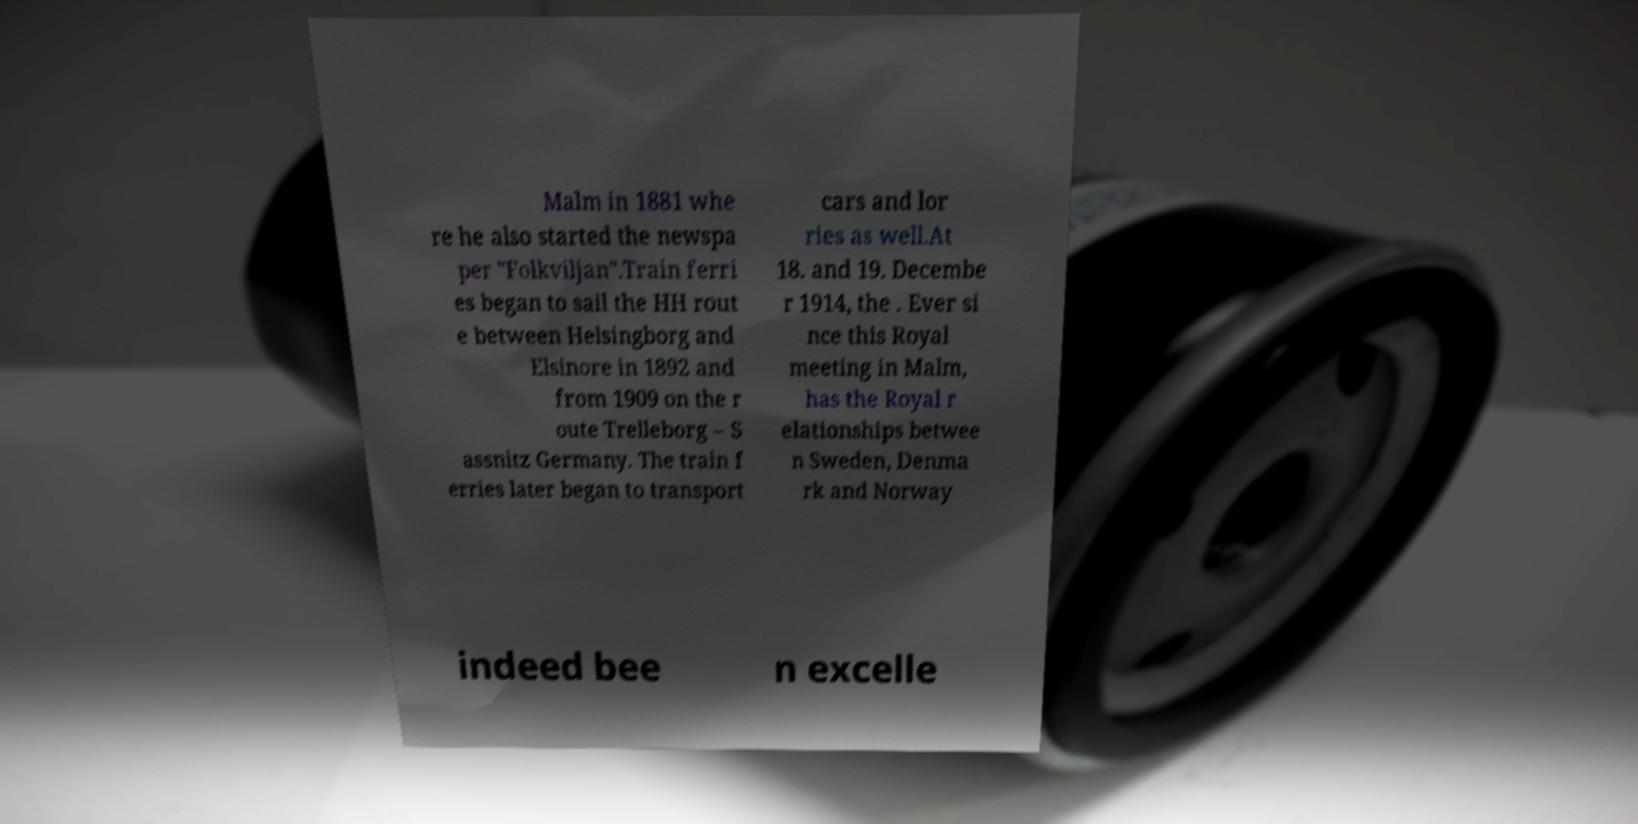Could you assist in decoding the text presented in this image and type it out clearly? Malm in 1881 whe re he also started the newspa per "Folkviljan".Train ferri es began to sail the HH rout e between Helsingborg and Elsinore in 1892 and from 1909 on the r oute Trelleborg – S assnitz Germany. The train f erries later began to transport cars and lor ries as well.At 18. and 19. Decembe r 1914, the . Ever si nce this Royal meeting in Malm, has the Royal r elationships betwee n Sweden, Denma rk and Norway indeed bee n excelle 